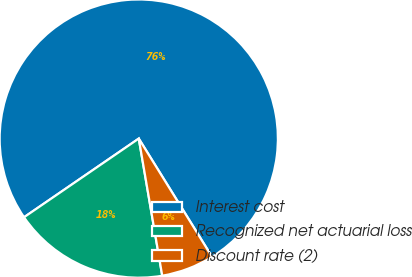Convert chart. <chart><loc_0><loc_0><loc_500><loc_500><pie_chart><fcel>Interest cost<fcel>Recognized net actuarial loss<fcel>Discount rate (2)<nl><fcel>75.73%<fcel>18.13%<fcel>6.13%<nl></chart> 